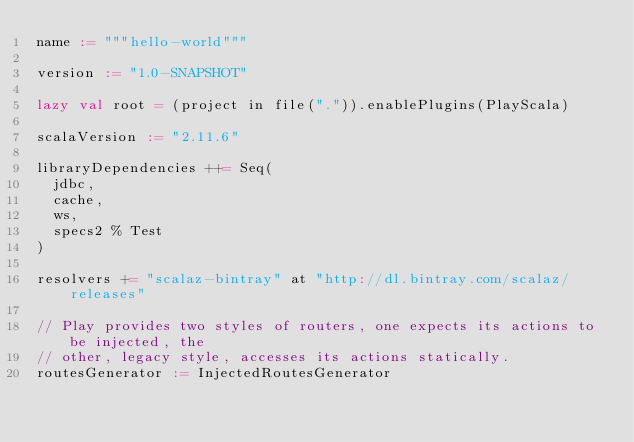<code> <loc_0><loc_0><loc_500><loc_500><_Scala_>name := """hello-world"""

version := "1.0-SNAPSHOT"

lazy val root = (project in file(".")).enablePlugins(PlayScala)

scalaVersion := "2.11.6"

libraryDependencies ++= Seq(
  jdbc,
  cache,
  ws,
  specs2 % Test
)

resolvers += "scalaz-bintray" at "http://dl.bintray.com/scalaz/releases"

// Play provides two styles of routers, one expects its actions to be injected, the
// other, legacy style, accesses its actions statically.
routesGenerator := InjectedRoutesGenerator
</code> 